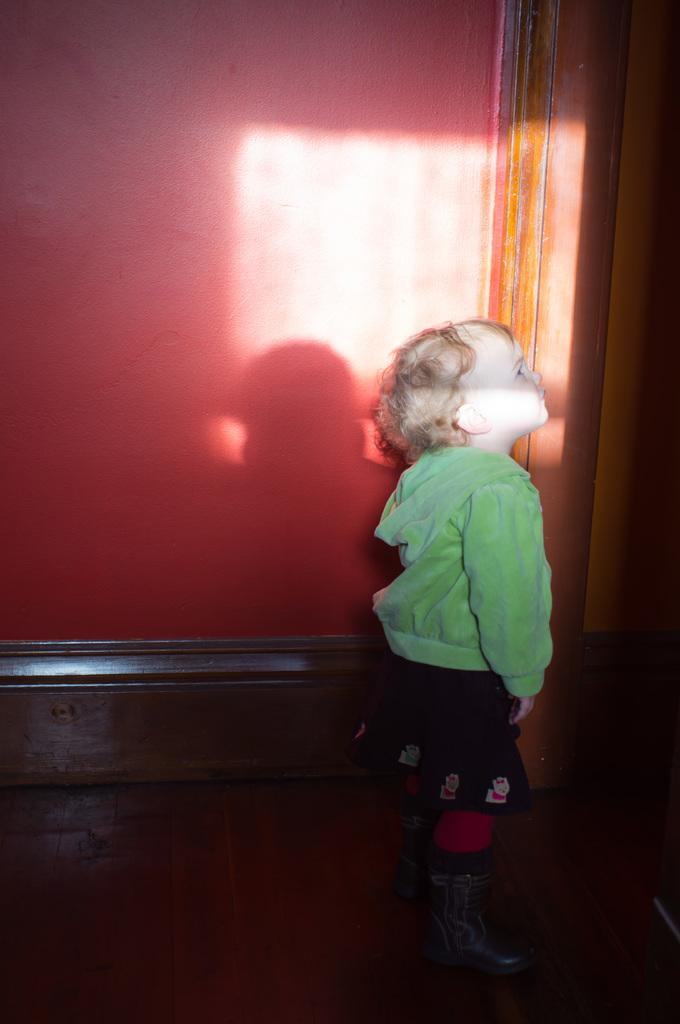What is the main subject in the foreground of the image? There is a small baby in the foreground of the foreground of the image. What can be seen in the background of the image? There is a wall visible in the background of the image. What type of cast can be seen on the baby's arm in the image? There is no cast visible on the baby's arm in the image. What is the baby talking about in the image? The image does not show the baby talking, so it cannot be determined what the baby might be discussing. 